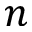Convert formula to latex. <formula><loc_0><loc_0><loc_500><loc_500>n</formula> 